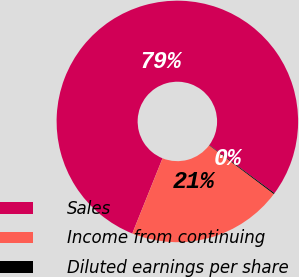Convert chart. <chart><loc_0><loc_0><loc_500><loc_500><pie_chart><fcel>Sales<fcel>Income from continuing<fcel>Diluted earnings per share<nl><fcel>79.04%<fcel>20.82%<fcel>0.14%<nl></chart> 